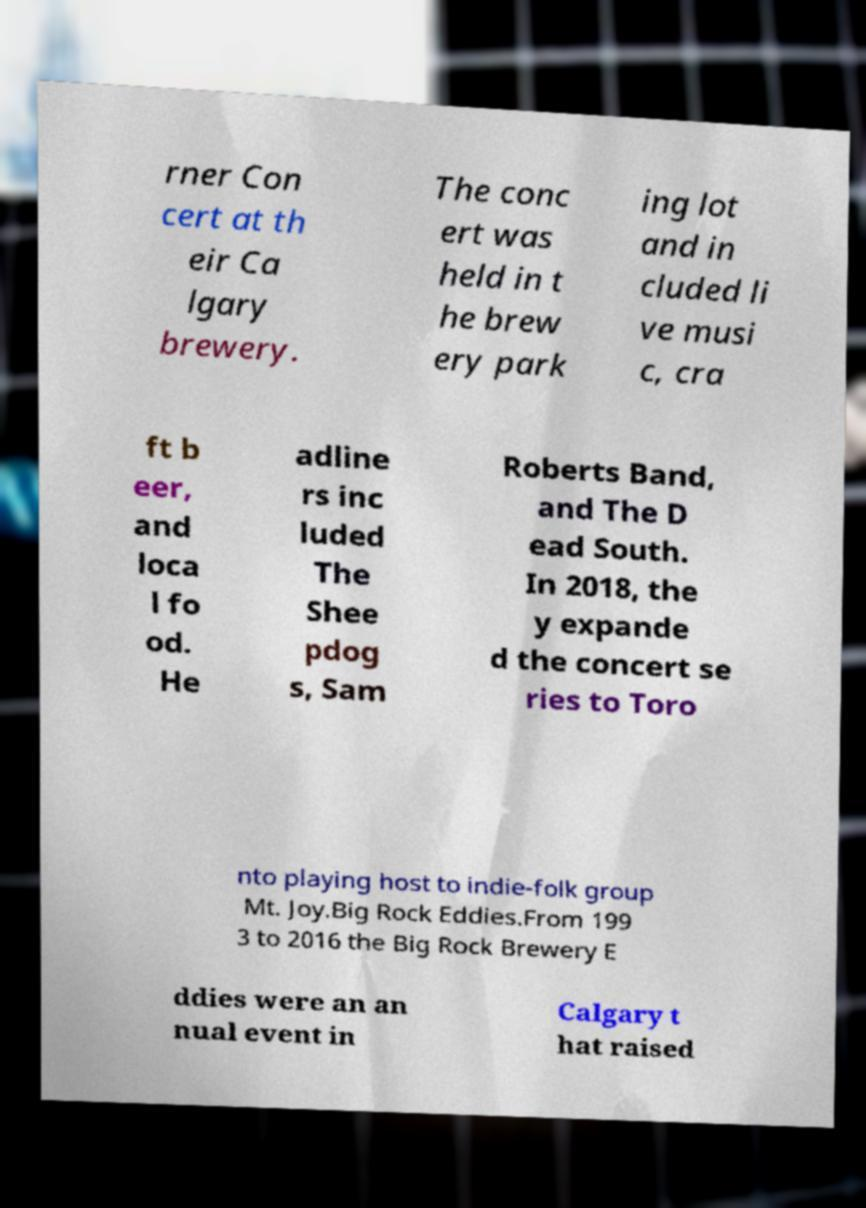Could you assist in decoding the text presented in this image and type it out clearly? rner Con cert at th eir Ca lgary brewery. The conc ert was held in t he brew ery park ing lot and in cluded li ve musi c, cra ft b eer, and loca l fo od. He adline rs inc luded The Shee pdog s, Sam Roberts Band, and The D ead South. In 2018, the y expande d the concert se ries to Toro nto playing host to indie-folk group Mt. Joy.Big Rock Eddies.From 199 3 to 2016 the Big Rock Brewery E ddies were an an nual event in Calgary t hat raised 